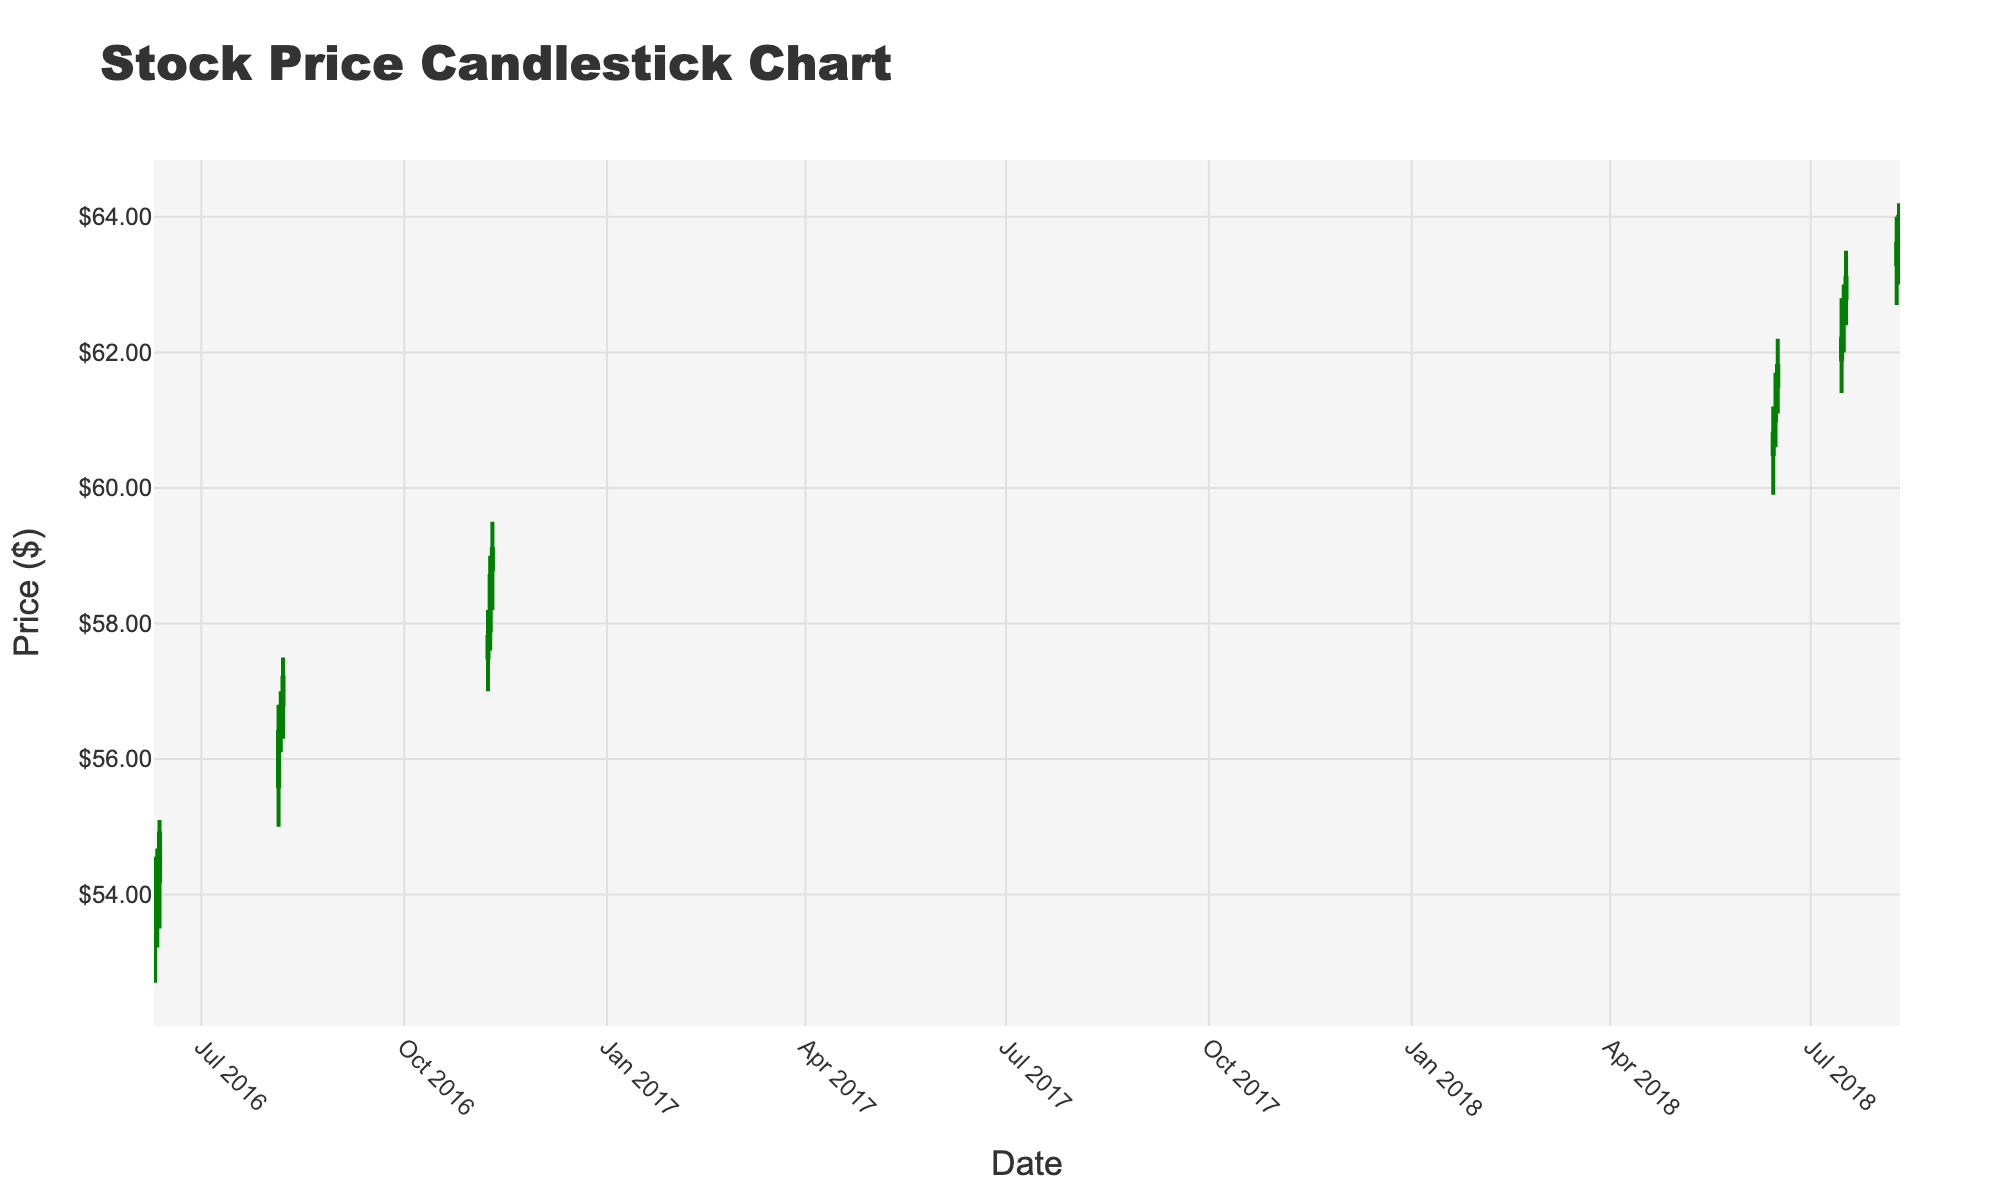What is the title of the figure? The title of a chart usually appears at the top and is written in larger font size. In this case, the title is "Stock Price Candlestick Chart".
Answer: Stock Price Candlestick Chart What are the colors used to indicate increasing and decreasing price lines? The colors for increasing and decreasing lines can be seen in the candlesticks. Here, the increasing line color is green and the decreasing line color is red.
Answer: Green and Red How many data points are shown in the figure? By counting each individual candlestick in the figure, we identify that there are 16 data points.
Answer: 16 Which day had the highest closing price during the given data range? The highest closing prices can be seen by observing the top of the candlestick bodies. The highest closing price of $64.00 is observed on August 10th, 2018.
Answer: August 10, 2018 What was the stock's closing price on June 12, 2016? To find the closing price on a specific date, locate the candlestick corresponding to June 12, 2016. The closing price is $54.90.
Answer: $54.90 Compare the opening price of the stock on August 6, 2016, with its closing price on August 7, 2016. Which was higher? By examining the candlestick corresponding to August 6, 2016, the opening price is $56.50. For August 7, 2016, the closing price is $57.20. The closing price on August 7, 2016, is higher.
Answer: Closing price on August 7, 2016 What was the range of stock prices on July 15, 2018 (from lowest to highest)? The range of the stock prices on July 15, 2018, can be found by looking at the lowest and highest points of the candlestick. The price range was from $61.40 to $62.80.
Answer: $61.40 to $62.80 What was the trend of the stock price during the dates of the 2016 Olympics (August 5-7, 2016)? To identify the trend during the 2016 Olympics, observe the candlesticks from August 5 to August 7, 2016. Each day's price increased, showing an upward trend.
Answer: Upward trend How did the stock price change on June 15, 2018, compared to the previous day? Check the closing price on June 14, 2018 ($60.80) and compare it with the closing price on June 15, 2018 ($61.10). The price increased by $0.30.
Answer: Increased by $0.30 What was the average closing price during the data points in August 2018? To find the average closing price in August 2018, sum the closing prices on August 9 ($63.60) and August 10 ($64.00), then divide by the 2 data points. ($63.60 + $64.00) / 2 = $63.80
Answer: $63.80 